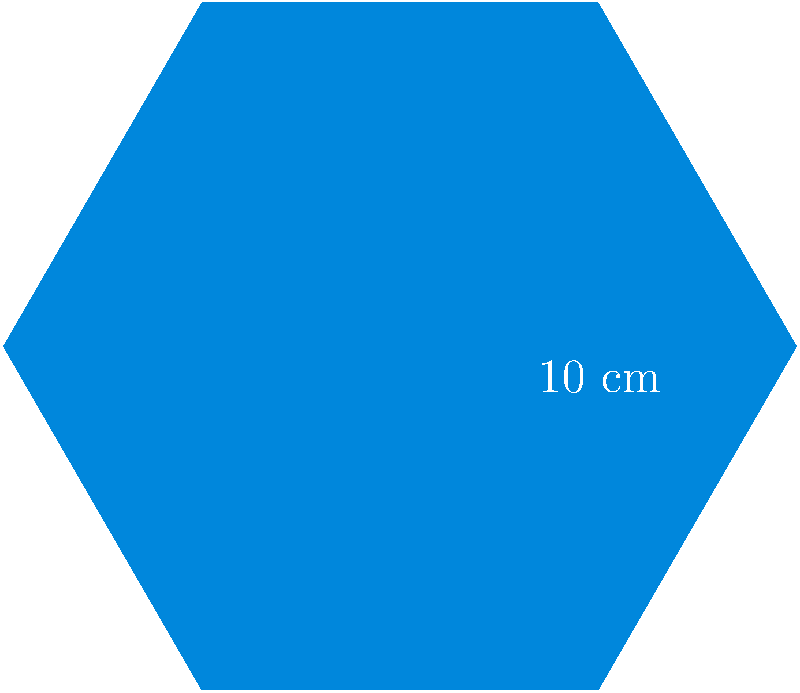The Conservative Party logo is a regular hexagon with side length 10 cm. Calculate the area of the logo in square centimeters. Round your answer to the nearest whole number. To calculate the area of a regular hexagon, we can use the formula:

$$ A = \frac{3\sqrt{3}}{2} s^2 $$

Where $A$ is the area and $s$ is the side length.

Step 1: Identify the side length
$s = 10$ cm

Step 2: Substitute the value into the formula
$$ A = \frac{3\sqrt{3}}{2} (10)^2 $$

Step 3: Calculate
$$ A = \frac{3\sqrt{3}}{2} \cdot 100 $$
$$ A = 150\sqrt{3} $$
$$ A \approx 259.8077 \text{ cm}^2 $$

Step 4: Round to the nearest whole number
$$ A \approx 260 \text{ cm}^2 $$
Answer: 260 cm² 